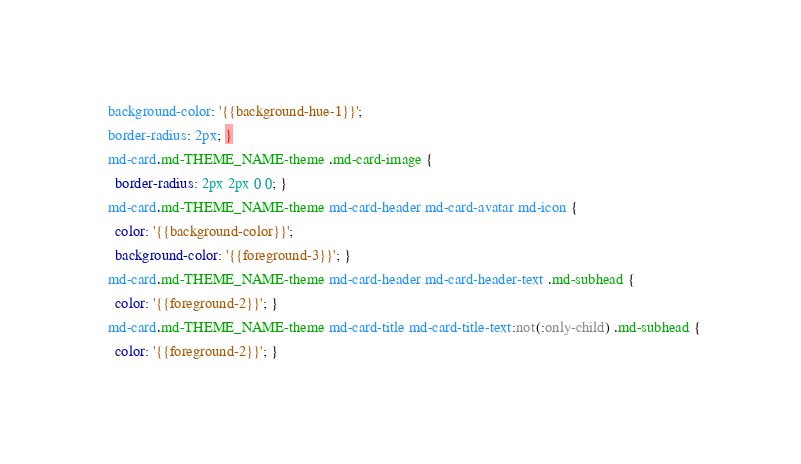Convert code to text. <code><loc_0><loc_0><loc_500><loc_500><_CSS_>  background-color: '{{background-hue-1}}';
  border-radius: 2px; }
  md-card.md-THEME_NAME-theme .md-card-image {
    border-radius: 2px 2px 0 0; }
  md-card.md-THEME_NAME-theme md-card-header md-card-avatar md-icon {
    color: '{{background-color}}';
    background-color: '{{foreground-3}}'; }
  md-card.md-THEME_NAME-theme md-card-header md-card-header-text .md-subhead {
    color: '{{foreground-2}}'; }
  md-card.md-THEME_NAME-theme md-card-title md-card-title-text:not(:only-child) .md-subhead {
    color: '{{foreground-2}}'; }
</code> 